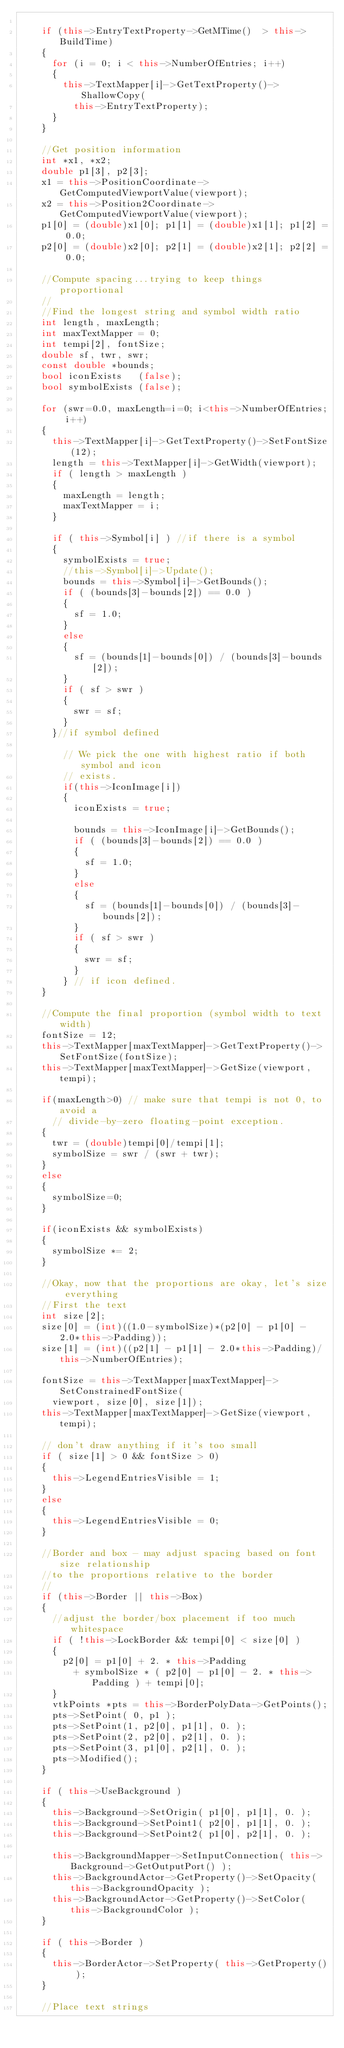Convert code to text. <code><loc_0><loc_0><loc_500><loc_500><_C++_>
    if (this->EntryTextProperty->GetMTime()  > this->BuildTime)
    {
      for (i = 0; i < this->NumberOfEntries; i++)
      {
        this->TextMapper[i]->GetTextProperty()->ShallowCopy(
          this->EntryTextProperty);
      }
    }

    //Get position information
    int *x1, *x2;
    double p1[3], p2[3];
    x1 = this->PositionCoordinate->GetComputedViewportValue(viewport);
    x2 = this->Position2Coordinate->GetComputedViewportValue(viewport);
    p1[0] = (double)x1[0]; p1[1] = (double)x1[1]; p1[2] = 0.0;
    p2[0] = (double)x2[0]; p2[1] = (double)x2[1]; p2[2] = 0.0;

    //Compute spacing...trying to keep things proportional
    //
    //Find the longest string and symbol width ratio
    int length, maxLength;
    int maxTextMapper = 0;
    int tempi[2], fontSize;
    double sf, twr, swr;
    const double *bounds;
    bool iconExists   (false);
    bool symbolExists (false);

    for (swr=0.0, maxLength=i=0; i<this->NumberOfEntries; i++)
    {
      this->TextMapper[i]->GetTextProperty()->SetFontSize(12);
      length = this->TextMapper[i]->GetWidth(viewport);
      if ( length > maxLength )
      {
        maxLength = length;
        maxTextMapper = i;
      }

      if ( this->Symbol[i] ) //if there is a symbol
      {
        symbolExists = true;
        //this->Symbol[i]->Update();
        bounds = this->Symbol[i]->GetBounds();
        if ( (bounds[3]-bounds[2]) == 0.0 )
        {
          sf = 1.0;
        }
        else
        {
          sf = (bounds[1]-bounds[0]) / (bounds[3]-bounds[2]);
        }
        if ( sf > swr )
        {
          swr = sf;
        }
      }//if symbol defined

        // We pick the one with highest ratio if both symbol and icon
        // exists.
        if(this->IconImage[i])
        {
          iconExists = true;

          bounds = this->IconImage[i]->GetBounds();
          if ( (bounds[3]-bounds[2]) == 0.0 )
          {
            sf = 1.0;
          }
          else
          {
            sf = (bounds[1]-bounds[0]) / (bounds[3]-bounds[2]);
          }
          if ( sf > swr )
          {
            swr = sf;
          }
        } // if icon defined.
    }

    //Compute the final proportion (symbol width to text width)
    fontSize = 12;
    this->TextMapper[maxTextMapper]->GetTextProperty()->SetFontSize(fontSize);
    this->TextMapper[maxTextMapper]->GetSize(viewport,tempi);

    if(maxLength>0) // make sure that tempi is not 0, to avoid a
      // divide-by-zero floating-point exception.
    {
      twr = (double)tempi[0]/tempi[1];
      symbolSize = swr / (swr + twr);
    }
    else
    {
      symbolSize=0;
    }

    if(iconExists && symbolExists)
    {
      symbolSize *= 2;
    }

    //Okay, now that the proportions are okay, let's size everything
    //First the text
    int size[2];
    size[0] = (int)((1.0-symbolSize)*(p2[0] - p1[0] - 2.0*this->Padding));
    size[1] = (int)((p2[1] - p1[1] - 2.0*this->Padding)/this->NumberOfEntries);

    fontSize = this->TextMapper[maxTextMapper]->SetConstrainedFontSize(
      viewport, size[0], size[1]);
    this->TextMapper[maxTextMapper]->GetSize(viewport,tempi);

    // don't draw anything if it's too small
    if ( size[1] > 0 && fontSize > 0)
    {
      this->LegendEntriesVisible = 1;
    }
    else
    {
      this->LegendEntriesVisible = 0;
    }

    //Border and box - may adjust spacing based on font size relationship
    //to the proportions relative to the border
    //
    if (this->Border || this->Box)
    {
      //adjust the border/box placement if too much whitespace
      if ( !this->LockBorder && tempi[0] < size[0] )
      {
        p2[0] = p1[0] + 2. * this->Padding
          + symbolSize * ( p2[0] - p1[0] - 2. * this->Padding ) + tempi[0];
      }
      vtkPoints *pts = this->BorderPolyData->GetPoints();
      pts->SetPoint( 0, p1 );
      pts->SetPoint(1, p2[0], p1[1], 0. );
      pts->SetPoint(2, p2[0], p2[1], 0. );
      pts->SetPoint(3, p1[0], p2[1], 0. );
      pts->Modified();
    }

    if ( this->UseBackground )
    {
      this->Background->SetOrigin( p1[0], p1[1], 0. );
      this->Background->SetPoint1( p2[0], p1[1], 0. );
      this->Background->SetPoint2( p1[0], p2[1], 0. );

      this->BackgroundMapper->SetInputConnection( this->Background->GetOutputPort() );
      this->BackgroundActor->GetProperty()->SetOpacity( this->BackgroundOpacity );
      this->BackgroundActor->GetProperty()->SetColor( this->BackgroundColor );
    }

    if ( this->Border )
    {
      this->BorderActor->SetProperty( this->GetProperty() );
    }

    //Place text strings</code> 